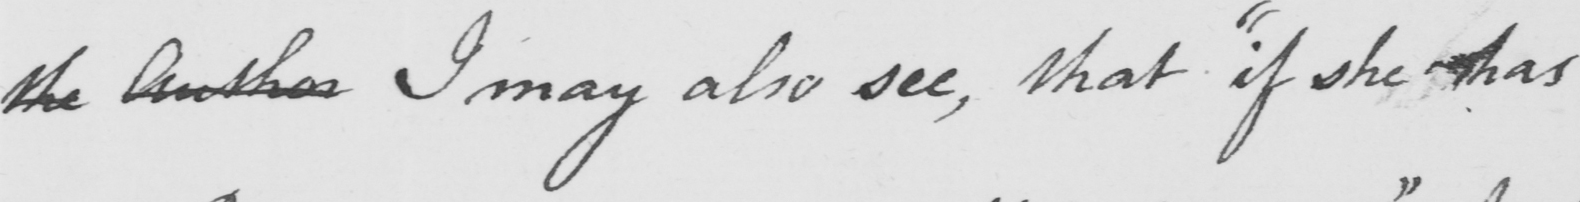Please transcribe the handwritten text in this image. the Author I may also see, that "if she has 